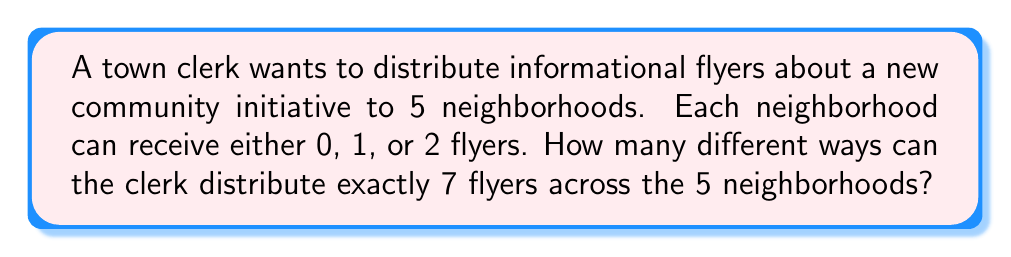Help me with this question. Let's approach this step-by-step using the stars and bars method:

1) We need to distribute 7 identical flyers (stars) among 5 neighborhoods (bins).

2) Each neighborhood can receive 0, 1, or 2 flyers. This is a restricted stars and bars problem.

3) We can solve this using the generating function method:
   Let $x^i$ represent giving $i$ flyers to a neighborhood.
   The generating function for each neighborhood is: $1 + x + x^2$

4) For all 5 neighborhoods, we need the coefficient of $x^7$ in:
   $$(1 + x + x^2)^5$$

5) Expanding this using the binomial theorem:
   $$\sum_{i=0}^5 \binom{5}{i}(x + x^2)^i(1)^{5-i}$$

6) We're interested in terms where the exponent of $x$ is 7. This can happen when:
   - We choose 3 neighborhoods to get 2 flyers and 1 to get 1 flyer: $\binom{5}{3}\binom{3}{1}$
   - We choose 2 neighborhoods to get 2 flyers and 3 to get 1 flyer: $\binom{5}{2}\binom{3}{3}$

7) Adding these up:
   $$\binom{5}{3}\binom{3}{1} + \binom{5}{2}\binom{3}{3} = 10 \cdot 3 + 10 \cdot 1 = 30 + 10 = 40$$

Therefore, there are 40 different ways to distribute the flyers.
Answer: 40 